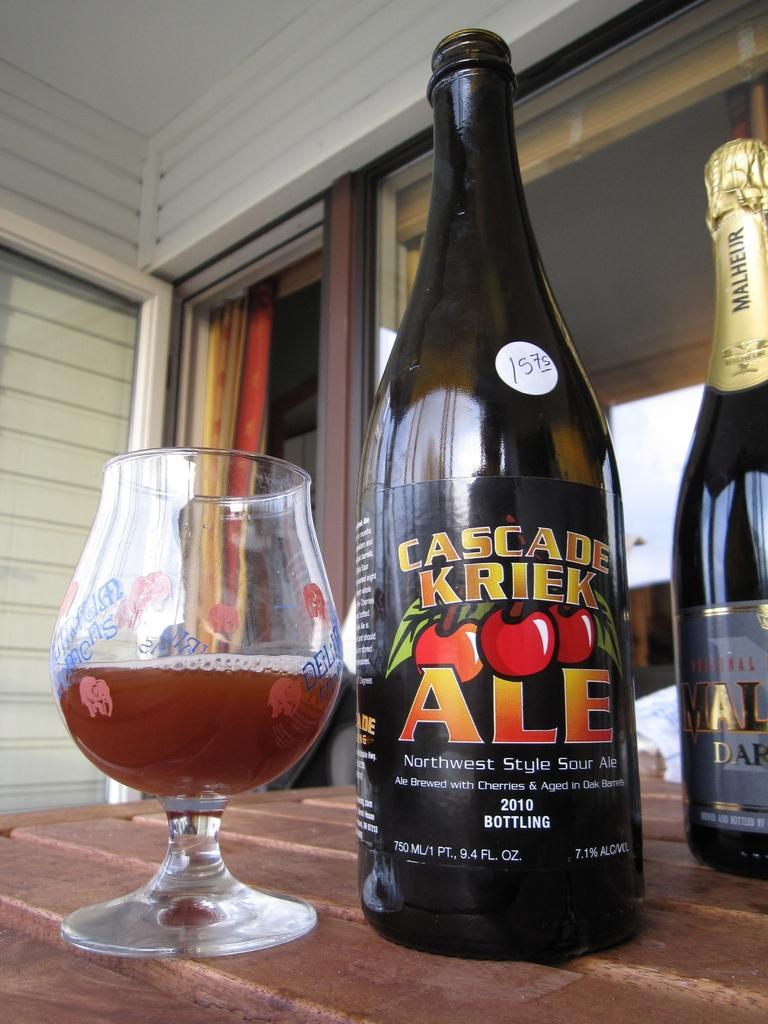<image>
Give a short and clear explanation of the subsequent image. Cascade Kriek Ale bottle next to a brandy snifter with less than half a glass of the beer on a wooden table outside on a porch. 